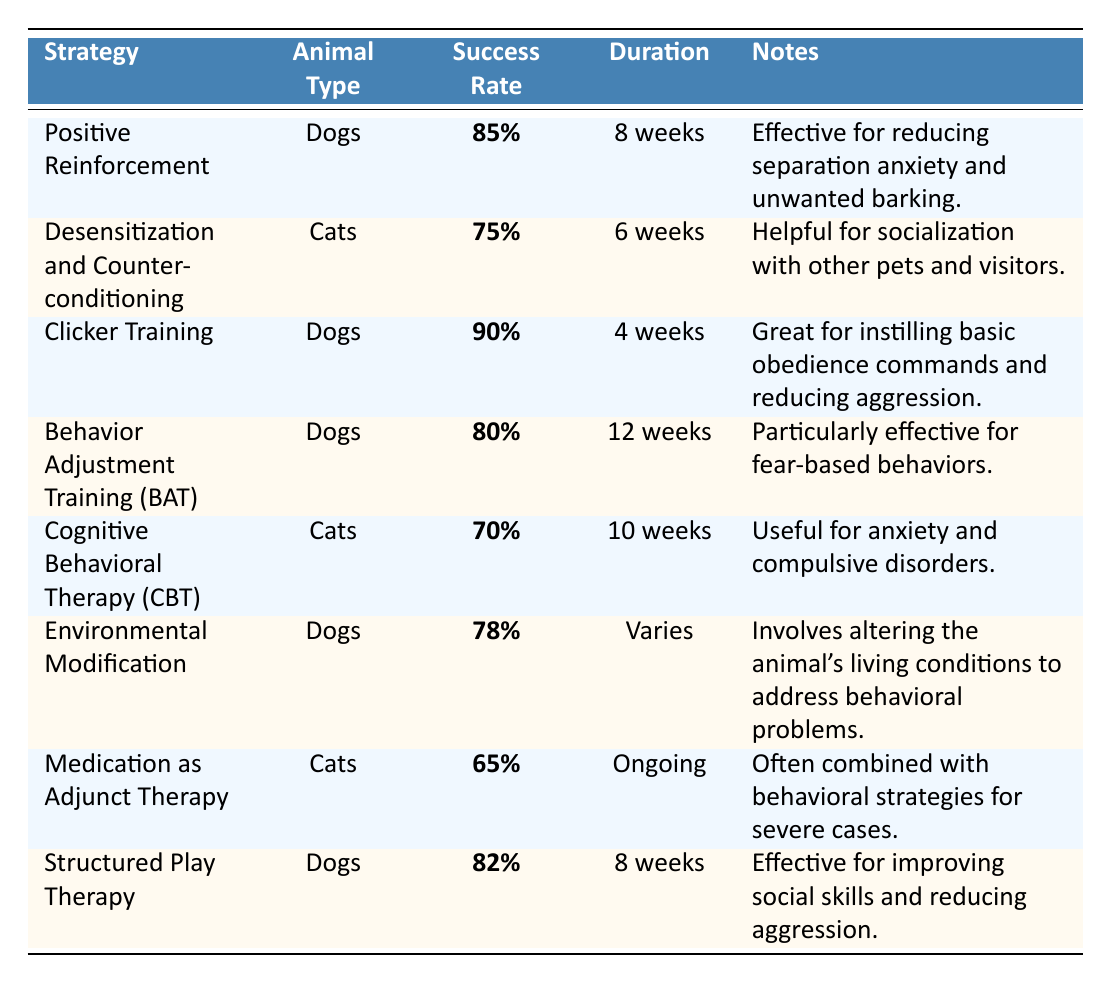What is the success rate of Clicker Training for dogs? The table specifies that Clicker Training has a success rate of 90% for dogs.
Answer: 90% Which behavior modification strategy has the lowest success rate for cats? Examining the success rates for cats in the table, Medication as Adjunct Therapy has the lowest success rate at 65%.
Answer: 65% How long does it take for the Behavior Adjustment Training (BAT) to be effective? The table indicates that the duration for Behavior Adjustment Training (BAT) is 12 weeks.
Answer: 12 weeks What is the average success rate of the strategies listed for dogs? Adding the success rates for dogs: 85% + 90% + 80% + 78% + 82% = 415%. Then dividing by the number of strategies, which is 5: 415% / 5 = 83%.
Answer: 83% Is Desensitization and Counter-conditioning effective for dogs? The table shows that this strategy is specifically listed for cats, not dogs, thus it is not effective for dogs.
Answer: No Which strategy has a higher success rate: Cognitive Behavioral Therapy (CBT) or Medication as Adjunct Therapy? CBT has a success rate of 70%, while Medication as Adjunct Therapy has a success rate of 65%. Since 70% is greater than 65%, CBT has a higher success rate.
Answer: Cognitive Behavioral Therapy (CBT) What is the duration for Positive Reinforcement, and how does it compare to Structured Play Therapy? The duration for Positive Reinforcement is 8 weeks, and for Structured Play Therapy, it is also 8 weeks. They are the same duration.
Answer: 8 weeks Which two strategies for dogs have success rates above 80%? The strategies with success rates above 80% for dogs are Clicker Training (90%) and Structured Play Therapy (82%).
Answer: Clicker Training and Structured Play Therapy If a strategy takes less than 10 weeks for completion, which animal type is it primarily associated with? The strategies that take less than 10 weeks are Clicker Training (4 weeks), Positive Reinforcement (8 weeks), and Desensitization and Counter-conditioning (6 weeks), with dogs associated with Clicker Training and Positive Reinforcement, and cats associated with Desensitization.
Answer: Both dogs and cats What percent success difference is there between Clicker Training and Environmental Modification for dogs? Clicker Training has a success rate of 90%, while Environmental Modification has a success rate of 78%. The difference is 90% - 78% = 12%.
Answer: 12% 